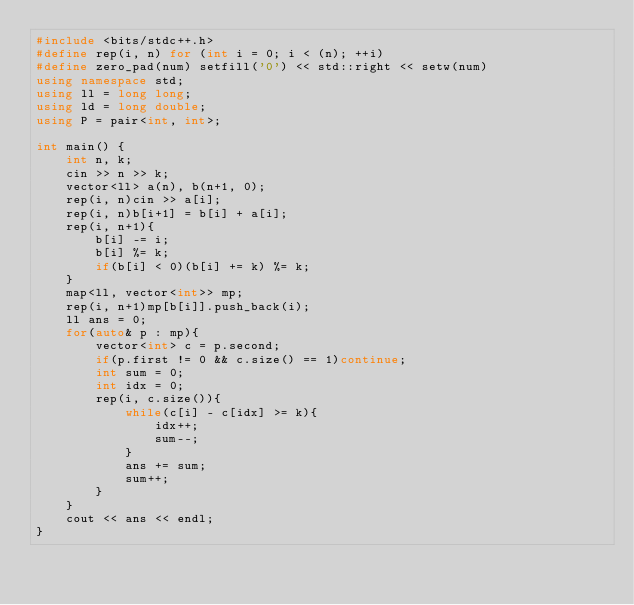<code> <loc_0><loc_0><loc_500><loc_500><_C++_>#include <bits/stdc++.h>
#define rep(i, n) for (int i = 0; i < (n); ++i)
#define zero_pad(num) setfill('0') << std::right << setw(num)
using namespace std;
using ll = long long;
using ld = long double;
using P = pair<int, int>;

int main() {
    int n, k;
    cin >> n >> k;
    vector<ll> a(n), b(n+1, 0);
    rep(i, n)cin >> a[i];
    rep(i, n)b[i+1] = b[i] + a[i];
    rep(i, n+1){
        b[i] -= i;
        b[i] %= k;
        if(b[i] < 0)(b[i] += k) %= k;
    }
    map<ll, vector<int>> mp;
    rep(i, n+1)mp[b[i]].push_back(i);
    ll ans = 0;
    for(auto& p : mp){
        vector<int> c = p.second;
        if(p.first != 0 && c.size() == 1)continue;
        int sum = 0;
        int idx = 0;
        rep(i, c.size()){
            while(c[i] - c[idx] >= k){
                idx++;
                sum--;
            }
            ans += sum;
            sum++;
        }
    }
    cout << ans << endl;
}</code> 